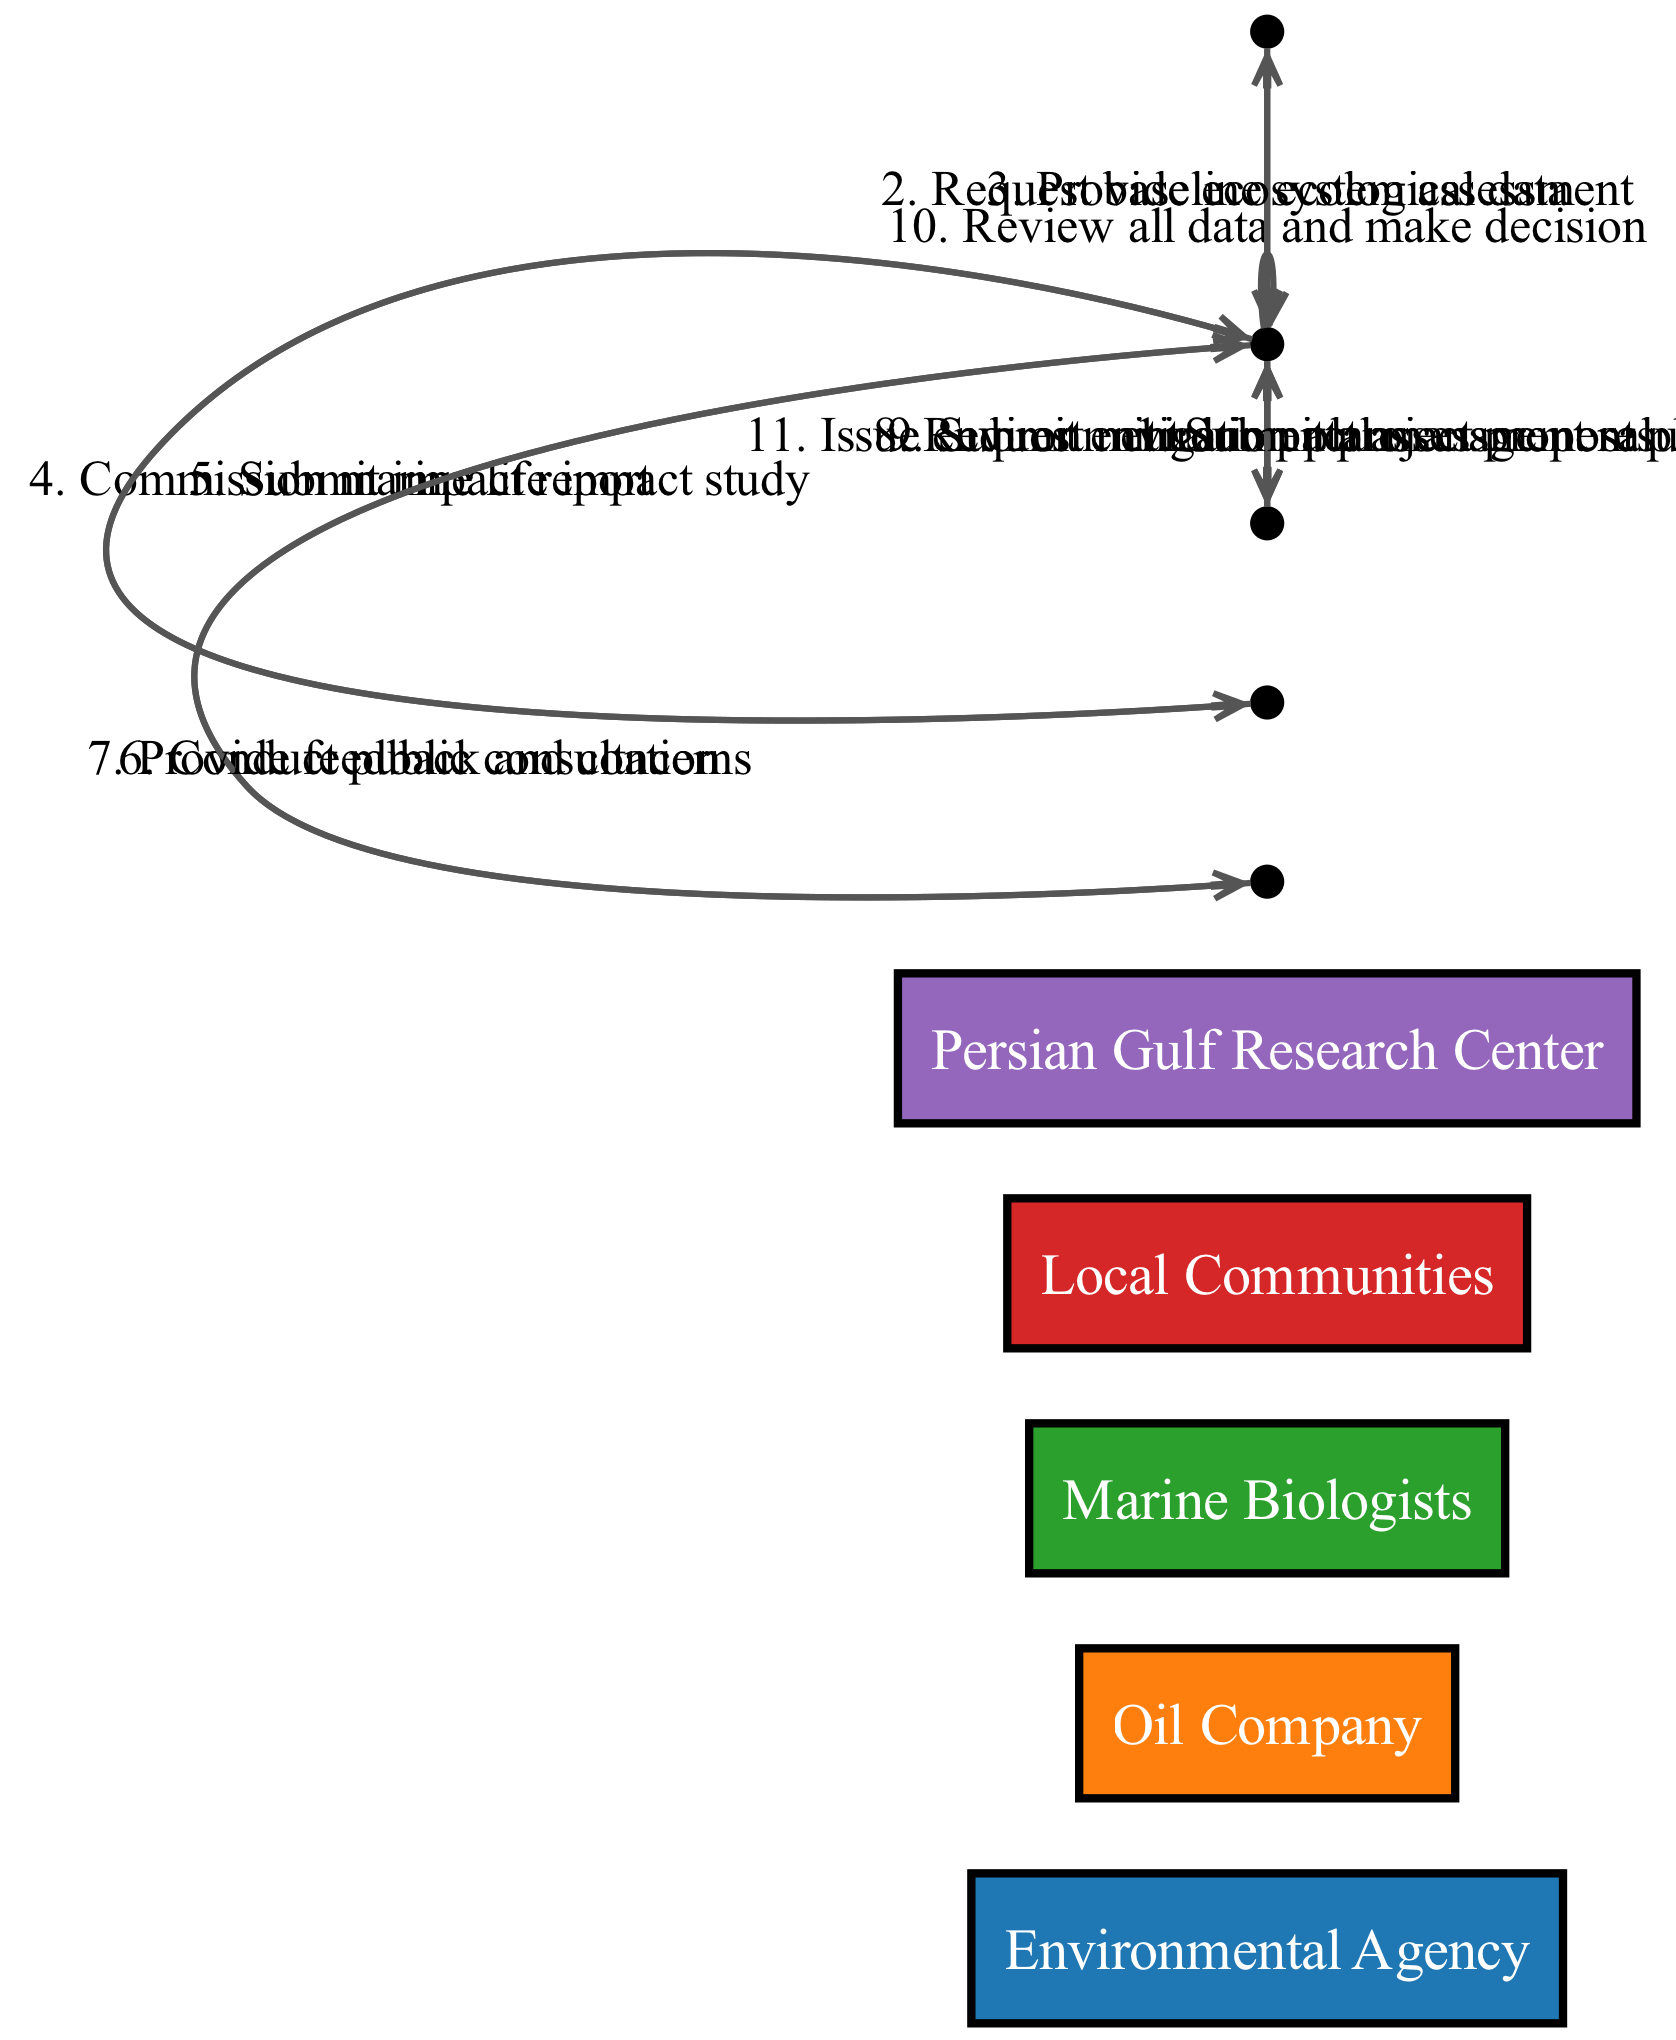What is the first step in the sequence? The first message in the sequence diagram is from "Oil Company" to "Environmental Agency" with the message "Submit project proposal". This indicates that the oil company begins the assessment process by submitting a proposal.
Answer: Submit project proposal How many actors are involved in this diagram? The diagram includes five distinct actors: Environmental Agency, Oil Company, Marine Biologists, Local Communities, and Persian Gulf Research Center. By counting each unique actor, we arrive at the total.
Answer: Five What message does the Environmental Agency send to the Marine Biologists? The Environmental Agency commissions the marine life impact study by sending a message to the Marine Biologists, specifically requesting a study on the impact of the proposed drilling activities.
Answer: Commission marine life impact study What does the Oil Company submit after the public consultation? After conducting public consultations, the Environmental Agency requests mitigation plans from the Oil Company, which leads to the Oil Company submitting the environmental management plan as their response.
Answer: Submit environmental management plan Which actor provides feedback and concerns? Feedback and concerns are provided by the Local Communities after the Environmental Agency conducts public consultations, indicating their involvement and concern for the environmental impacts of the project.
Answer: Local Communities What are the two final actions taken by the Environmental Agency? The two final actions taken by the Environmental Agency are the review of all data followed by issuing the environmental impact assessment result. This sequence culminates in the final decision based on gathered information.
Answer: Review all data and issue environmental impact assessment result Which actor is responsible for providing baseline ecological data? The Persian Gulf Research Center is tasked by the Environmental Agency to provide baseline ecological data, making this actor crucial for understanding the pre-existing environmental conditions.
Answer: Persian Gulf Research Center How many messages are exchanged between the Local Communities and the Environmental Agency? The diagram shows one instance where the Local Communities provide feedback and concerns to the Environmental Agency after the public consultation. This indicates a direct interaction concerning the public's input.
Answer: One 